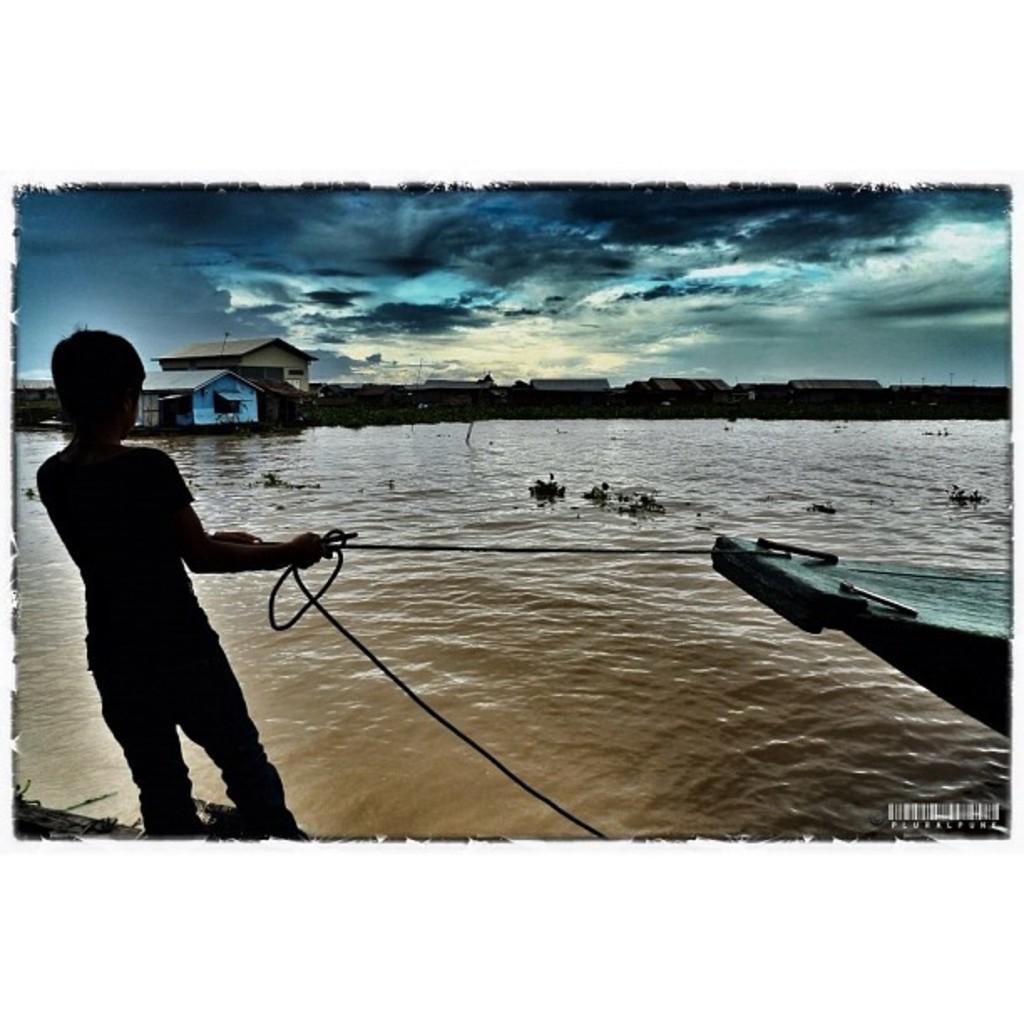Could you give a brief overview of what you see in this image? As we can see in the image there is water, boat and a person standing on the left side. In the background there are buildings. At the top there is sky and there are clouds. 